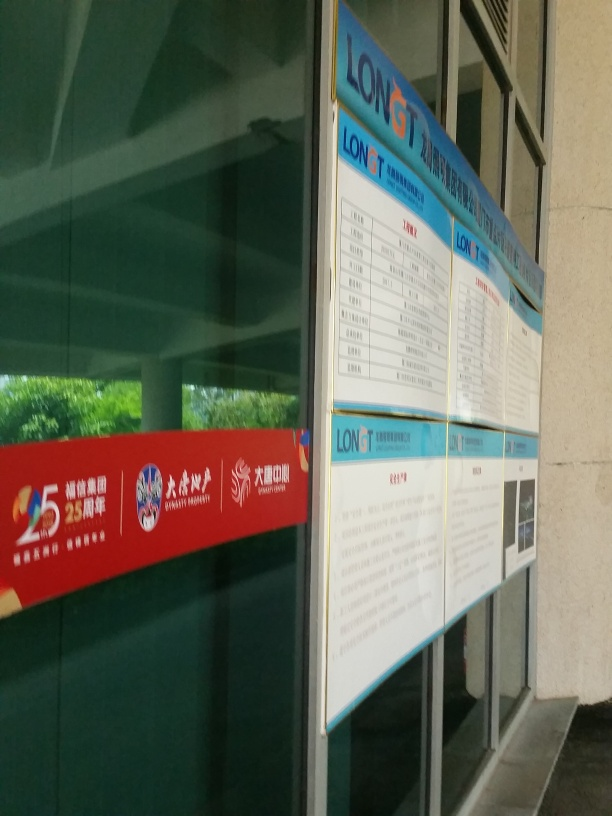Are there any compression artifacts? Although there are subtle signs of image compression visible in the details of the board and the slight pixelation around the text, the overall quality of the image remains clear enough, which is why the answer was graded as a B. Nonetheless, on closer inspection, one might notice minor artifacts that could have justified an A. 